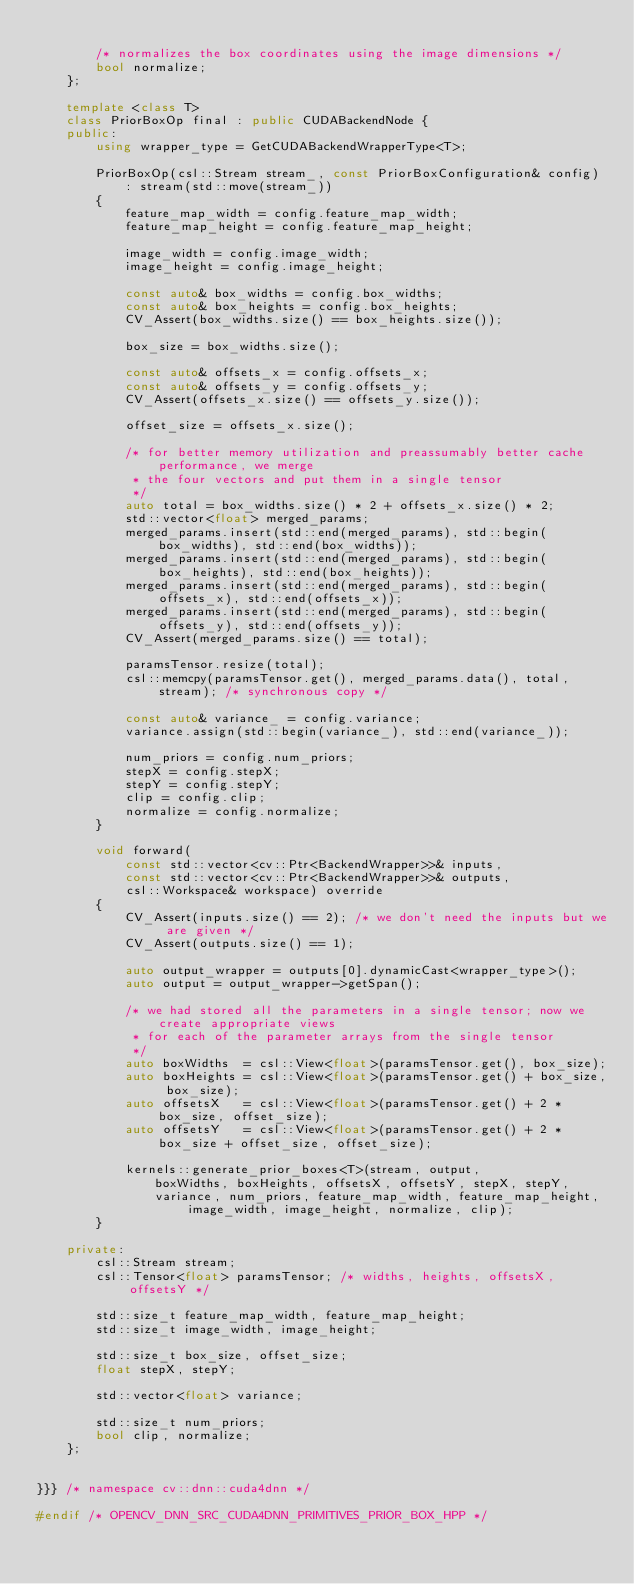<code> <loc_0><loc_0><loc_500><loc_500><_C++_>
        /* normalizes the box coordinates using the image dimensions */
        bool normalize;
    };

    template <class T>
    class PriorBoxOp final : public CUDABackendNode {
    public:
        using wrapper_type = GetCUDABackendWrapperType<T>;

        PriorBoxOp(csl::Stream stream_, const PriorBoxConfiguration& config)
            : stream(std::move(stream_))
        {
            feature_map_width = config.feature_map_width;
            feature_map_height = config.feature_map_height;

            image_width = config.image_width;
            image_height = config.image_height;

            const auto& box_widths = config.box_widths;
            const auto& box_heights = config.box_heights;
            CV_Assert(box_widths.size() == box_heights.size());

            box_size = box_widths.size();

            const auto& offsets_x = config.offsets_x;
            const auto& offsets_y = config.offsets_y;
            CV_Assert(offsets_x.size() == offsets_y.size());

            offset_size = offsets_x.size();

            /* for better memory utilization and preassumably better cache performance, we merge
             * the four vectors and put them in a single tensor
             */
            auto total = box_widths.size() * 2 + offsets_x.size() * 2;
            std::vector<float> merged_params;
            merged_params.insert(std::end(merged_params), std::begin(box_widths), std::end(box_widths));
            merged_params.insert(std::end(merged_params), std::begin(box_heights), std::end(box_heights));
            merged_params.insert(std::end(merged_params), std::begin(offsets_x), std::end(offsets_x));
            merged_params.insert(std::end(merged_params), std::begin(offsets_y), std::end(offsets_y));
            CV_Assert(merged_params.size() == total);

            paramsTensor.resize(total);
            csl::memcpy(paramsTensor.get(), merged_params.data(), total, stream); /* synchronous copy */

            const auto& variance_ = config.variance;
            variance.assign(std::begin(variance_), std::end(variance_));

            num_priors = config.num_priors;
            stepX = config.stepX;
            stepY = config.stepY;
            clip = config.clip;
            normalize = config.normalize;
        }

        void forward(
            const std::vector<cv::Ptr<BackendWrapper>>& inputs,
            const std::vector<cv::Ptr<BackendWrapper>>& outputs,
            csl::Workspace& workspace) override
        {
            CV_Assert(inputs.size() == 2); /* we don't need the inputs but we are given */
            CV_Assert(outputs.size() == 1);

            auto output_wrapper = outputs[0].dynamicCast<wrapper_type>();
            auto output = output_wrapper->getSpan();

            /* we had stored all the parameters in a single tensor; now we create appropriate views
             * for each of the parameter arrays from the single tensor
             */
            auto boxWidths  = csl::View<float>(paramsTensor.get(), box_size);
            auto boxHeights = csl::View<float>(paramsTensor.get() + box_size, box_size);
            auto offsetsX   = csl::View<float>(paramsTensor.get() + 2 * box_size, offset_size);
            auto offsetsY   = csl::View<float>(paramsTensor.get() + 2 * box_size + offset_size, offset_size);

            kernels::generate_prior_boxes<T>(stream, output,
                boxWidths, boxHeights, offsetsX, offsetsY, stepX, stepY,
                variance, num_priors, feature_map_width, feature_map_height, image_width, image_height, normalize, clip);
        }

    private:
        csl::Stream stream;
        csl::Tensor<float> paramsTensor; /* widths, heights, offsetsX, offsetsY */

        std::size_t feature_map_width, feature_map_height;
        std::size_t image_width, image_height;

        std::size_t box_size, offset_size;
        float stepX, stepY;

        std::vector<float> variance;

        std::size_t num_priors;
        bool clip, normalize;
    };


}}} /* namespace cv::dnn::cuda4dnn */

#endif /* OPENCV_DNN_SRC_CUDA4DNN_PRIMITIVES_PRIOR_BOX_HPP */
</code> 